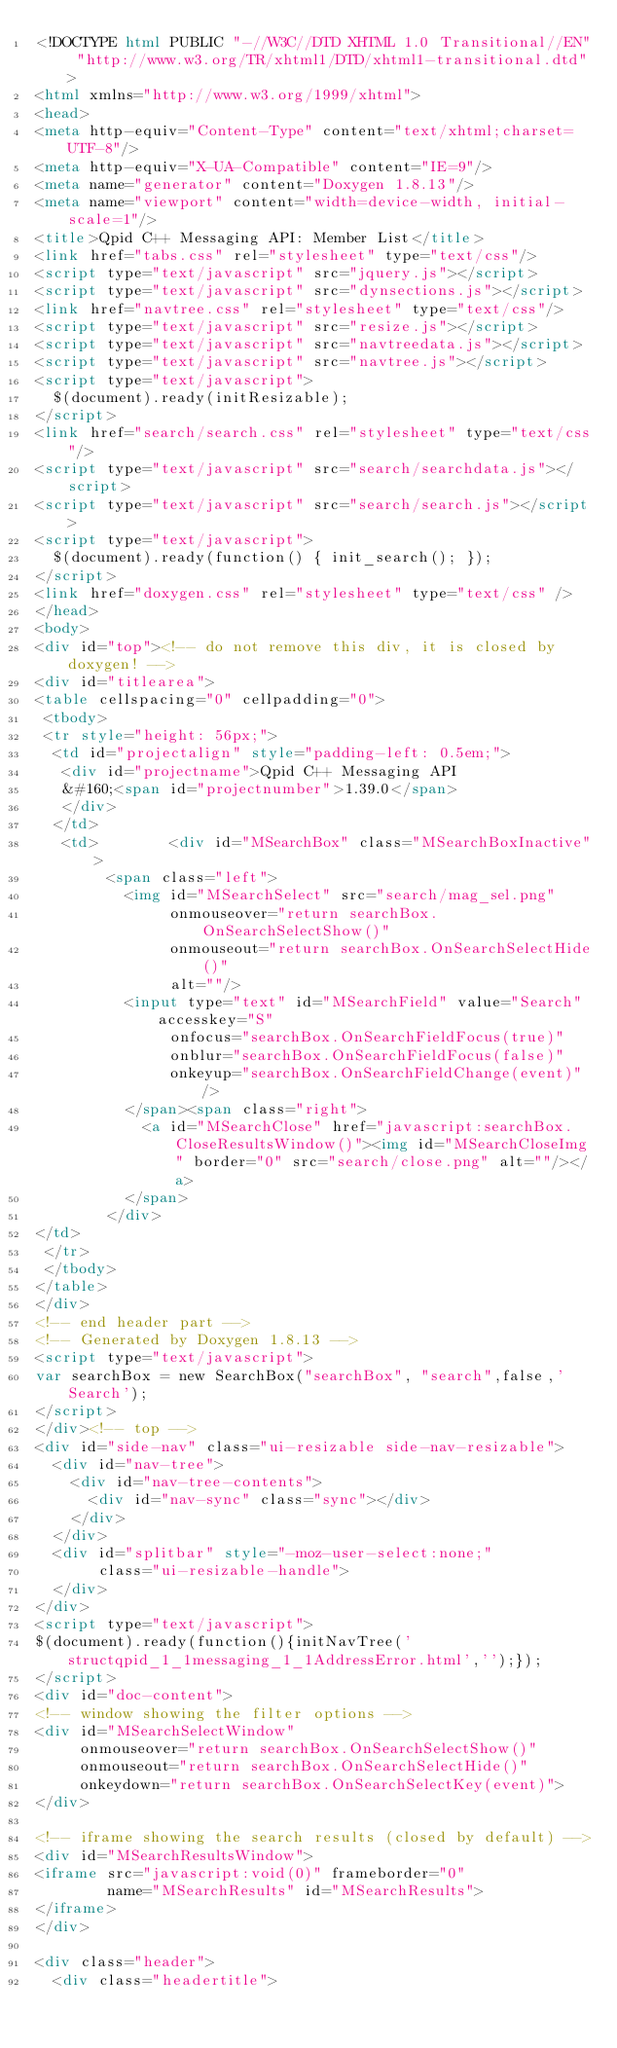Convert code to text. <code><loc_0><loc_0><loc_500><loc_500><_HTML_><!DOCTYPE html PUBLIC "-//W3C//DTD XHTML 1.0 Transitional//EN" "http://www.w3.org/TR/xhtml1/DTD/xhtml1-transitional.dtd">
<html xmlns="http://www.w3.org/1999/xhtml">
<head>
<meta http-equiv="Content-Type" content="text/xhtml;charset=UTF-8"/>
<meta http-equiv="X-UA-Compatible" content="IE=9"/>
<meta name="generator" content="Doxygen 1.8.13"/>
<meta name="viewport" content="width=device-width, initial-scale=1"/>
<title>Qpid C++ Messaging API: Member List</title>
<link href="tabs.css" rel="stylesheet" type="text/css"/>
<script type="text/javascript" src="jquery.js"></script>
<script type="text/javascript" src="dynsections.js"></script>
<link href="navtree.css" rel="stylesheet" type="text/css"/>
<script type="text/javascript" src="resize.js"></script>
<script type="text/javascript" src="navtreedata.js"></script>
<script type="text/javascript" src="navtree.js"></script>
<script type="text/javascript">
  $(document).ready(initResizable);
</script>
<link href="search/search.css" rel="stylesheet" type="text/css"/>
<script type="text/javascript" src="search/searchdata.js"></script>
<script type="text/javascript" src="search/search.js"></script>
<script type="text/javascript">
  $(document).ready(function() { init_search(); });
</script>
<link href="doxygen.css" rel="stylesheet" type="text/css" />
</head>
<body>
<div id="top"><!-- do not remove this div, it is closed by doxygen! -->
<div id="titlearea">
<table cellspacing="0" cellpadding="0">
 <tbody>
 <tr style="height: 56px;">
  <td id="projectalign" style="padding-left: 0.5em;">
   <div id="projectname">Qpid C++ Messaging API
   &#160;<span id="projectnumber">1.39.0</span>
   </div>
  </td>
   <td>        <div id="MSearchBox" class="MSearchBoxInactive">
        <span class="left">
          <img id="MSearchSelect" src="search/mag_sel.png"
               onmouseover="return searchBox.OnSearchSelectShow()"
               onmouseout="return searchBox.OnSearchSelectHide()"
               alt=""/>
          <input type="text" id="MSearchField" value="Search" accesskey="S"
               onfocus="searchBox.OnSearchFieldFocus(true)" 
               onblur="searchBox.OnSearchFieldFocus(false)" 
               onkeyup="searchBox.OnSearchFieldChange(event)"/>
          </span><span class="right">
            <a id="MSearchClose" href="javascript:searchBox.CloseResultsWindow()"><img id="MSearchCloseImg" border="0" src="search/close.png" alt=""/></a>
          </span>
        </div>
</td>
 </tr>
 </tbody>
</table>
</div>
<!-- end header part -->
<!-- Generated by Doxygen 1.8.13 -->
<script type="text/javascript">
var searchBox = new SearchBox("searchBox", "search",false,'Search');
</script>
</div><!-- top -->
<div id="side-nav" class="ui-resizable side-nav-resizable">
  <div id="nav-tree">
    <div id="nav-tree-contents">
      <div id="nav-sync" class="sync"></div>
    </div>
  </div>
  <div id="splitbar" style="-moz-user-select:none;" 
       class="ui-resizable-handle">
  </div>
</div>
<script type="text/javascript">
$(document).ready(function(){initNavTree('structqpid_1_1messaging_1_1AddressError.html','');});
</script>
<div id="doc-content">
<!-- window showing the filter options -->
<div id="MSearchSelectWindow"
     onmouseover="return searchBox.OnSearchSelectShow()"
     onmouseout="return searchBox.OnSearchSelectHide()"
     onkeydown="return searchBox.OnSearchSelectKey(event)">
</div>

<!-- iframe showing the search results (closed by default) -->
<div id="MSearchResultsWindow">
<iframe src="javascript:void(0)" frameborder="0" 
        name="MSearchResults" id="MSearchResults">
</iframe>
</div>

<div class="header">
  <div class="headertitle"></code> 